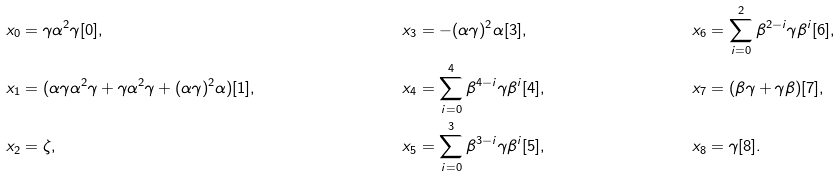Convert formula to latex. <formula><loc_0><loc_0><loc_500><loc_500>x _ { 0 } & = \gamma \alpha ^ { 2 } \gamma [ 0 ] , & x _ { 3 } & = - ( \alpha \gamma ) ^ { 2 } \alpha [ 3 ] , & x _ { 6 } & = \sum _ { i = 0 } ^ { 2 } \beta ^ { 2 - i } \gamma \beta ^ { i } [ 6 ] , \\ x _ { 1 } & = ( \alpha \gamma \alpha ^ { 2 } \gamma + \gamma \alpha ^ { 2 } \gamma + ( \alpha \gamma ) ^ { 2 } \alpha ) [ 1 ] , & x _ { 4 } & = \sum _ { i = 0 } ^ { 4 } \beta ^ { 4 - i } \gamma \beta ^ { i } [ 4 ] , & x _ { 7 } & = ( \beta \gamma + \gamma \beta ) [ 7 ] , \\ x _ { 2 } & = \zeta , & x _ { 5 } & = \sum _ { i = 0 } ^ { 3 } \beta ^ { 3 - i } \gamma \beta ^ { i } [ 5 ] , & x _ { 8 } & = \gamma [ 8 ] .</formula> 